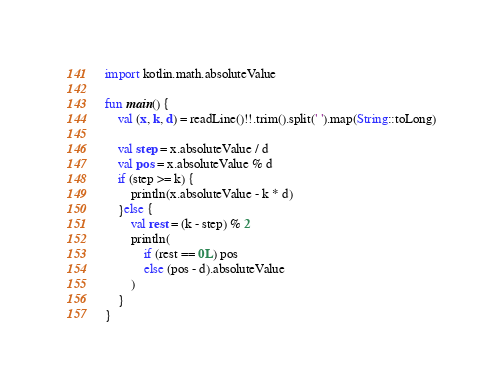<code> <loc_0><loc_0><loc_500><loc_500><_Kotlin_>import kotlin.math.absoluteValue

fun main() {
    val (x, k, d) = readLine()!!.trim().split(' ').map(String::toLong)

    val step = x.absoluteValue / d
    val pos = x.absoluteValue % d
    if (step >= k) {
        println(x.absoluteValue - k * d)
    }else {
        val rest = (k - step) % 2
        println(
            if (rest == 0L) pos
            else (pos - d).absoluteValue
        )
    }
}</code> 